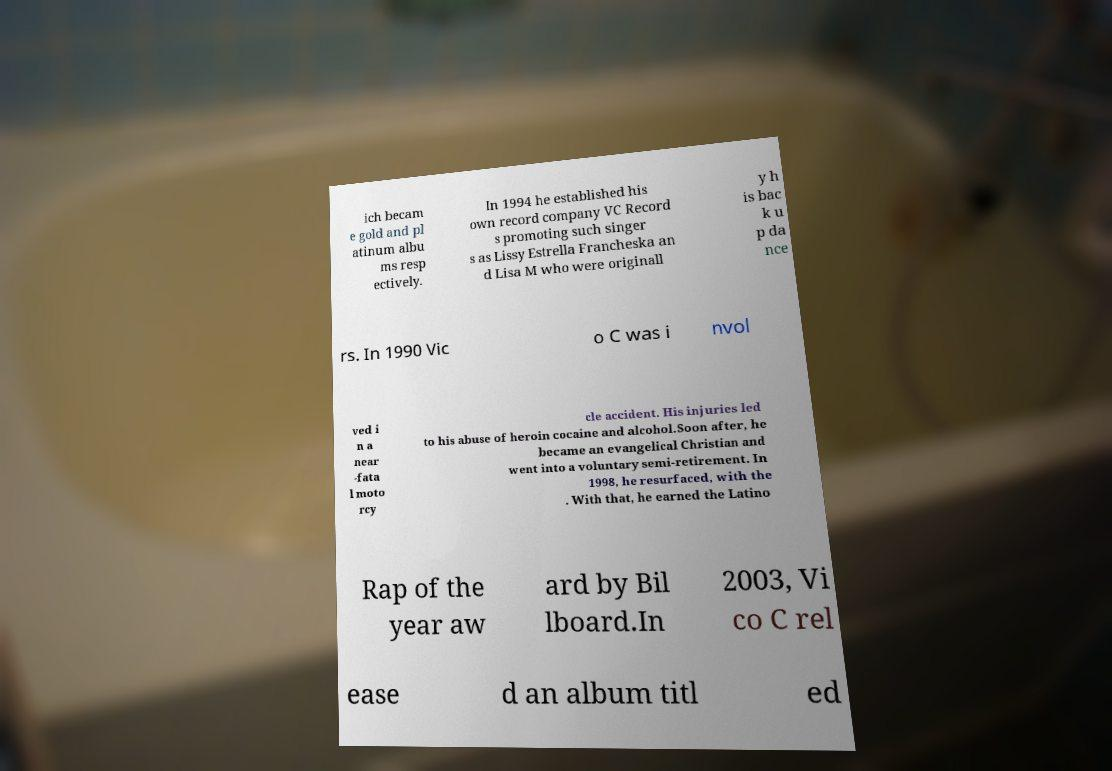For documentation purposes, I need the text within this image transcribed. Could you provide that? ich becam e gold and pl atinum albu ms resp ectively. In 1994 he established his own record company VC Record s promoting such singer s as Lissy Estrella Francheska an d Lisa M who were originall y h is bac k u p da nce rs. In 1990 Vic o C was i nvol ved i n a near -fata l moto rcy cle accident. His injuries led to his abuse of heroin cocaine and alcohol.Soon after, he became an evangelical Christian and went into a voluntary semi-retirement. In 1998, he resurfaced, with the . With that, he earned the Latino Rap of the year aw ard by Bil lboard.In 2003, Vi co C rel ease d an album titl ed 